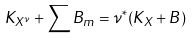<formula> <loc_0><loc_0><loc_500><loc_500>K _ { X ^ { \nu } } + \sum B _ { m } = \nu ^ { * } ( K _ { X } + B )</formula> 